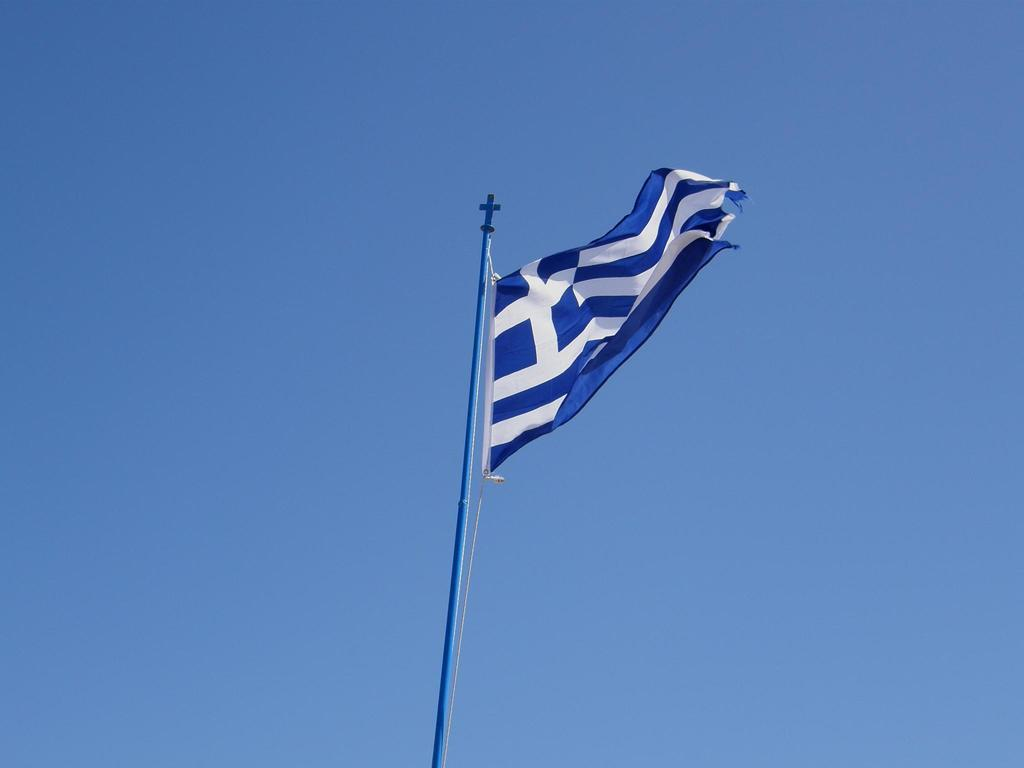What is the main subject in the center of the image? There is a flag in the center of the image. What can be seen in the background of the image? The sky is visible in the background of the image. How many parcels are being carried by the yak in the image? There is no yak or parcel present in the image. What type of glove is the person wearing in the image? There is no person or glove present in the image. 